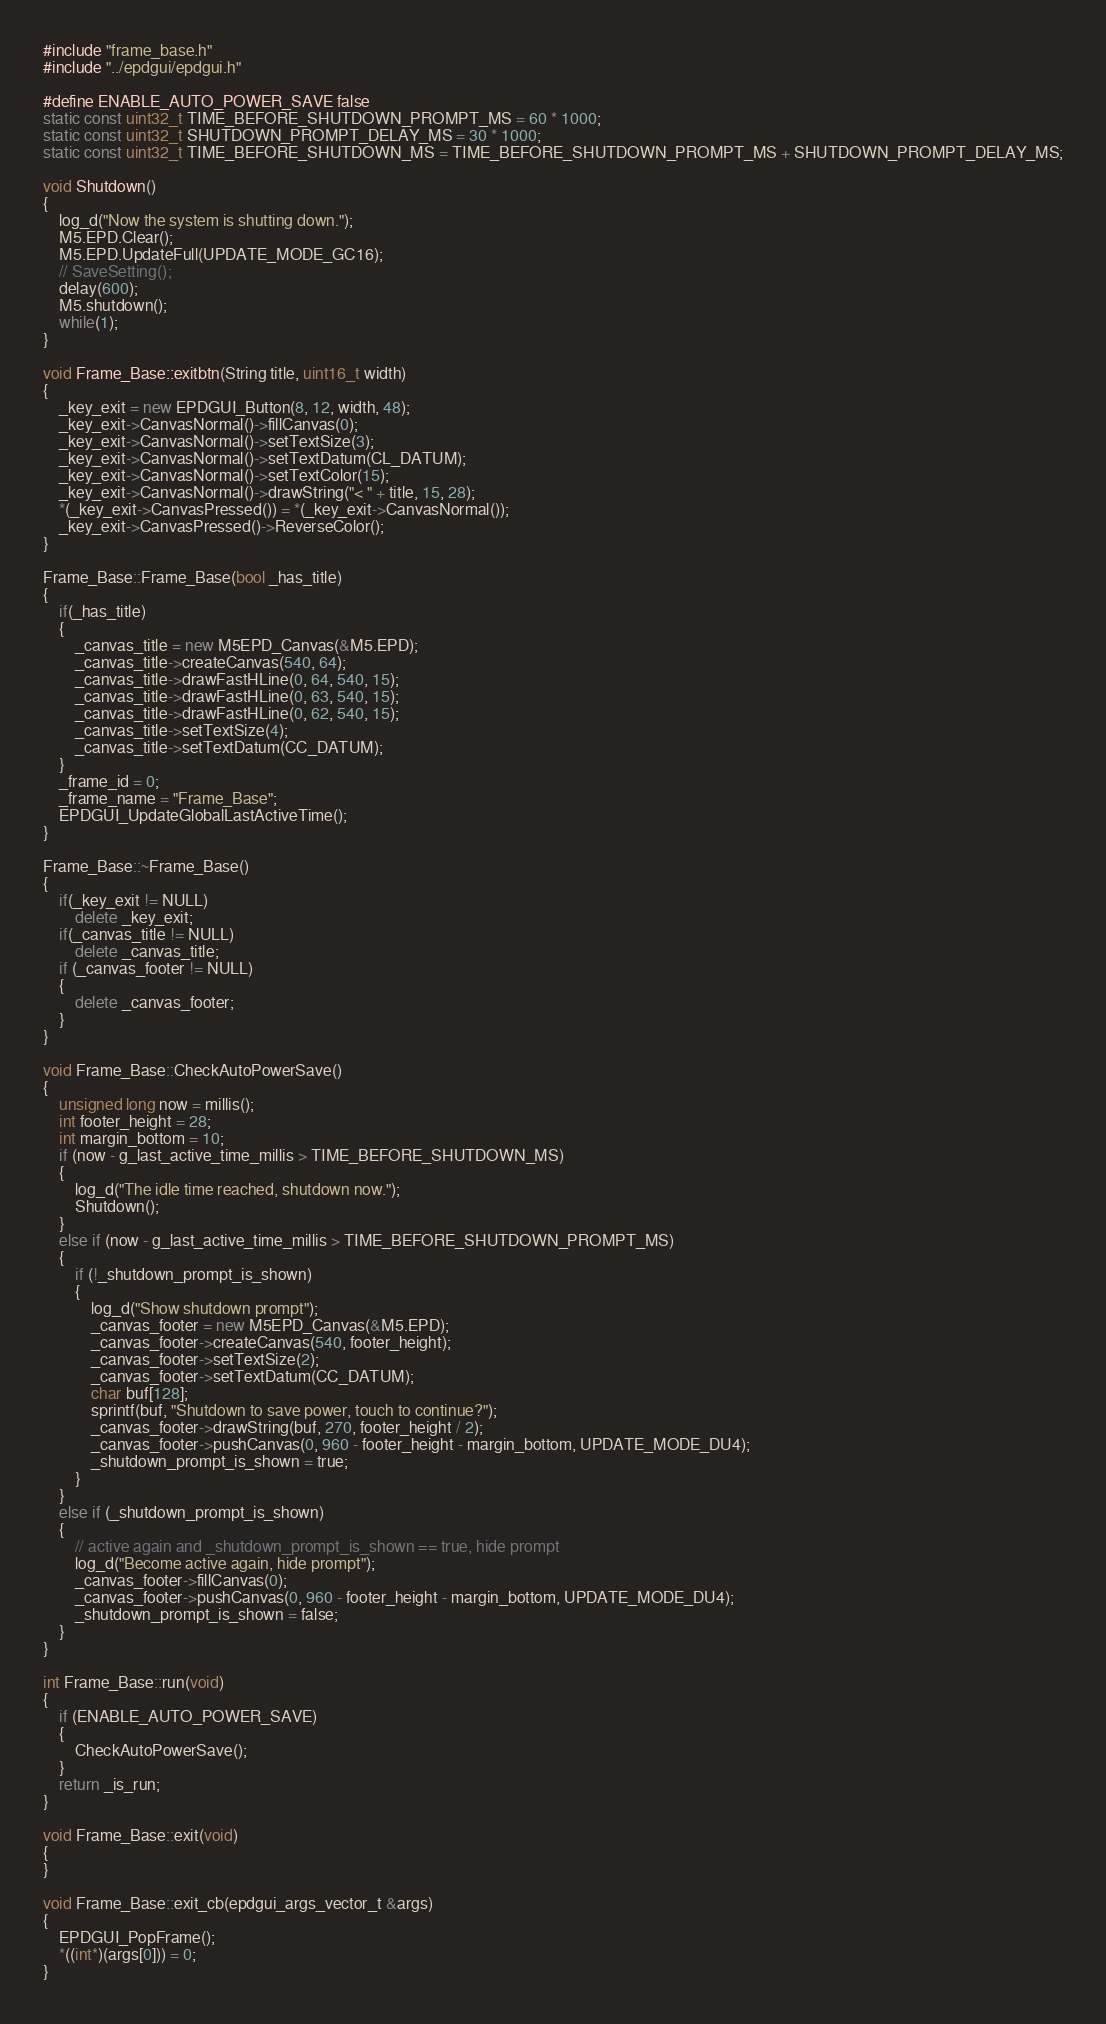<code> <loc_0><loc_0><loc_500><loc_500><_C++_>#include "frame_base.h"
#include "../epdgui/epdgui.h"

#define ENABLE_AUTO_POWER_SAVE false
static const uint32_t TIME_BEFORE_SHUTDOWN_PROMPT_MS = 60 * 1000;
static const uint32_t SHUTDOWN_PROMPT_DELAY_MS = 30 * 1000;
static const uint32_t TIME_BEFORE_SHUTDOWN_MS = TIME_BEFORE_SHUTDOWN_PROMPT_MS + SHUTDOWN_PROMPT_DELAY_MS;

void Shutdown()
{
    log_d("Now the system is shutting down.");
    M5.EPD.Clear();
    M5.EPD.UpdateFull(UPDATE_MODE_GC16);
    // SaveSetting();
    delay(600);
    M5.shutdown();
    while(1);
}

void Frame_Base::exitbtn(String title, uint16_t width)
{
    _key_exit = new EPDGUI_Button(8, 12, width, 48);
    _key_exit->CanvasNormal()->fillCanvas(0);
    _key_exit->CanvasNormal()->setTextSize(3);
    _key_exit->CanvasNormal()->setTextDatum(CL_DATUM);
    _key_exit->CanvasNormal()->setTextColor(15);
    _key_exit->CanvasNormal()->drawString("< " + title, 15, 28);
    *(_key_exit->CanvasPressed()) = *(_key_exit->CanvasNormal());
    _key_exit->CanvasPressed()->ReverseColor();
}

Frame_Base::Frame_Base(bool _has_title)
{
    if(_has_title)
    {
        _canvas_title = new M5EPD_Canvas(&M5.EPD);
        _canvas_title->createCanvas(540, 64);
        _canvas_title->drawFastHLine(0, 64, 540, 15);
        _canvas_title->drawFastHLine(0, 63, 540, 15);
        _canvas_title->drawFastHLine(0, 62, 540, 15);
        _canvas_title->setTextSize(4);
        _canvas_title->setTextDatum(CC_DATUM);
    }
    _frame_id = 0;
    _frame_name = "Frame_Base";
    EPDGUI_UpdateGlobalLastActiveTime();
}

Frame_Base::~Frame_Base() 
{
    if(_key_exit != NULL)
        delete _key_exit;
    if(_canvas_title != NULL)
        delete _canvas_title;
    if (_canvas_footer != NULL)
    {
        delete _canvas_footer;
    }
}

void Frame_Base::CheckAutoPowerSave()
{
    unsigned long now = millis();
    int footer_height = 28;
    int margin_bottom = 10;
    if (now - g_last_active_time_millis > TIME_BEFORE_SHUTDOWN_MS)
    {
        log_d("The idle time reached, shutdown now.");
        Shutdown();
    }
    else if (now - g_last_active_time_millis > TIME_BEFORE_SHUTDOWN_PROMPT_MS)
    {
        if (!_shutdown_prompt_is_shown)
        {
            log_d("Show shutdown prompt");
            _canvas_footer = new M5EPD_Canvas(&M5.EPD);
            _canvas_footer->createCanvas(540, footer_height);
            _canvas_footer->setTextSize(2);
            _canvas_footer->setTextDatum(CC_DATUM);
            char buf[128];
            sprintf(buf, "Shutdown to save power, touch to continue?");
            _canvas_footer->drawString(buf, 270, footer_height / 2);
            _canvas_footer->pushCanvas(0, 960 - footer_height - margin_bottom, UPDATE_MODE_DU4);
            _shutdown_prompt_is_shown = true;
        }
    }
    else if (_shutdown_prompt_is_shown)
    {
        // active again and _shutdown_prompt_is_shown == true, hide prompt
        log_d("Become active again, hide prompt");
        _canvas_footer->fillCanvas(0);
        _canvas_footer->pushCanvas(0, 960 - footer_height - margin_bottom, UPDATE_MODE_DU4);
        _shutdown_prompt_is_shown = false;
    }
}

int Frame_Base::run(void)
{
    if (ENABLE_AUTO_POWER_SAVE)
    {
        CheckAutoPowerSave();
    }
    return _is_run;
}

void Frame_Base::exit(void)
{
}

void Frame_Base::exit_cb(epdgui_args_vector_t &args)
{
    EPDGUI_PopFrame();
    *((int*)(args[0])) = 0;
}</code> 